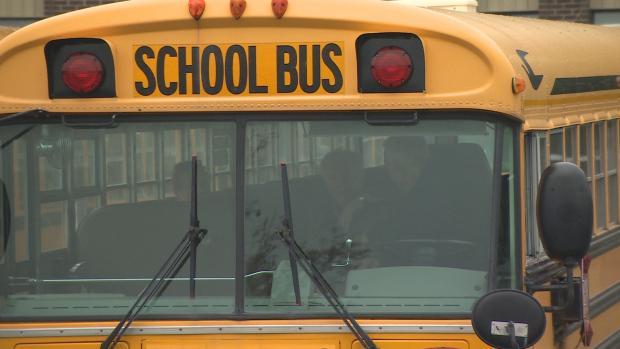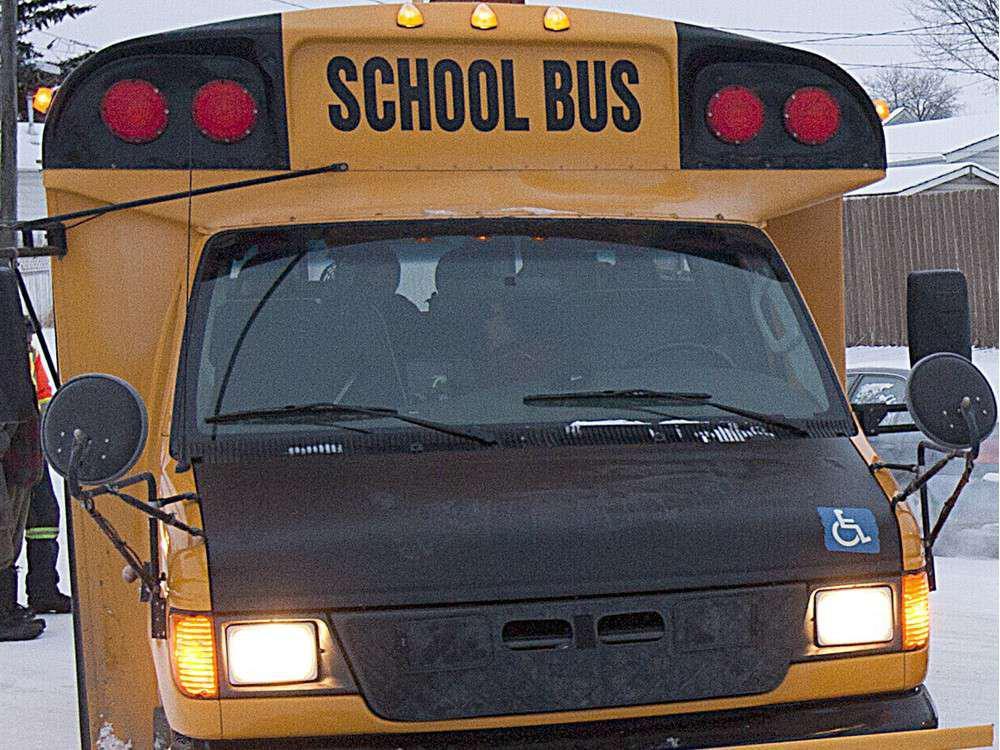The first image is the image on the left, the second image is the image on the right. Given the left and right images, does the statement "There are exactly two buses." hold true? Answer yes or no. Yes. The first image is the image on the left, the second image is the image on the right. Considering the images on both sides, is "Two rectangular rear view mirrors are visible in the righthand image but neither are located on the right side of the image." valid? Answer yes or no. No. 